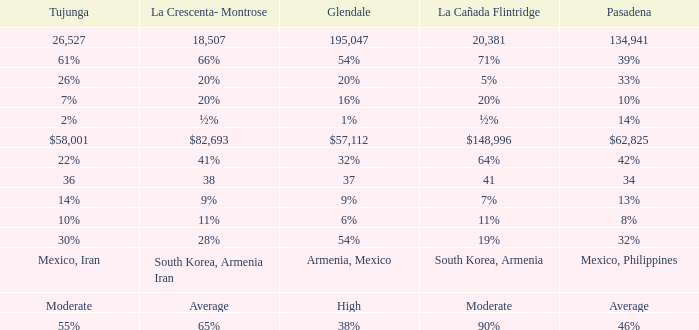What is the percentage of Glendale when La Canada Flintridge is 5%? 20%. 